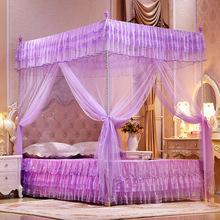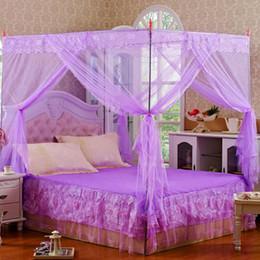The first image is the image on the left, the second image is the image on the right. Assess this claim about the two images: "A brunette woman in a negligee is posed with one of the purple canopy beds.". Correct or not? Answer yes or no. No. The first image is the image on the left, the second image is the image on the right. For the images shown, is this caption "One of the images includes a human." true? Answer yes or no. No. 